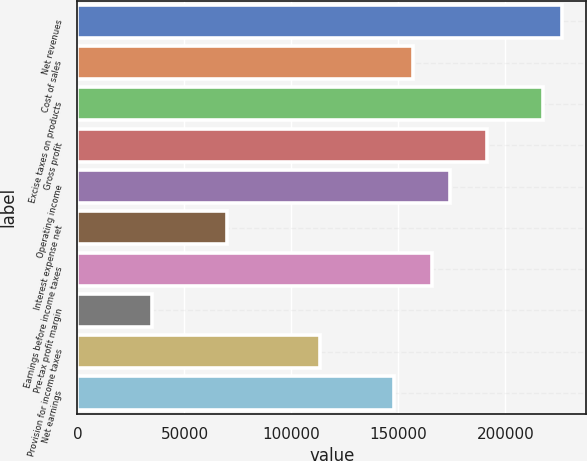Convert chart to OTSL. <chart><loc_0><loc_0><loc_500><loc_500><bar_chart><fcel>Net revenues<fcel>Cost of sales<fcel>Excise taxes on products<fcel>Gross profit<fcel>Operating income<fcel>Interest expense net<fcel>Earnings before income taxes<fcel>Pre-tax profit margin<fcel>Provision for income taxes<fcel>Net earnings<nl><fcel>226455<fcel>156777<fcel>217745<fcel>191616<fcel>174197<fcel>69680.7<fcel>165487<fcel>34842<fcel>113229<fcel>148068<nl></chart> 